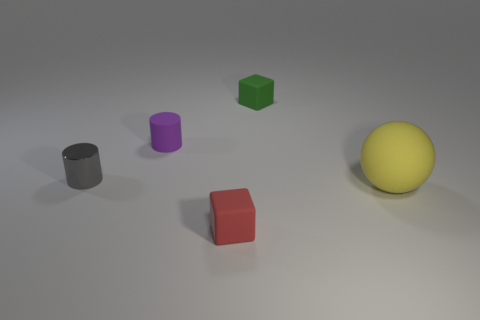Add 3 large rubber spheres. How many objects exist? 8 Subtract all cylinders. How many objects are left? 3 Add 4 tiny cubes. How many tiny cubes exist? 6 Subtract 1 purple cylinders. How many objects are left? 4 Subtract all rubber cylinders. Subtract all small rubber cubes. How many objects are left? 2 Add 3 rubber cylinders. How many rubber cylinders are left? 4 